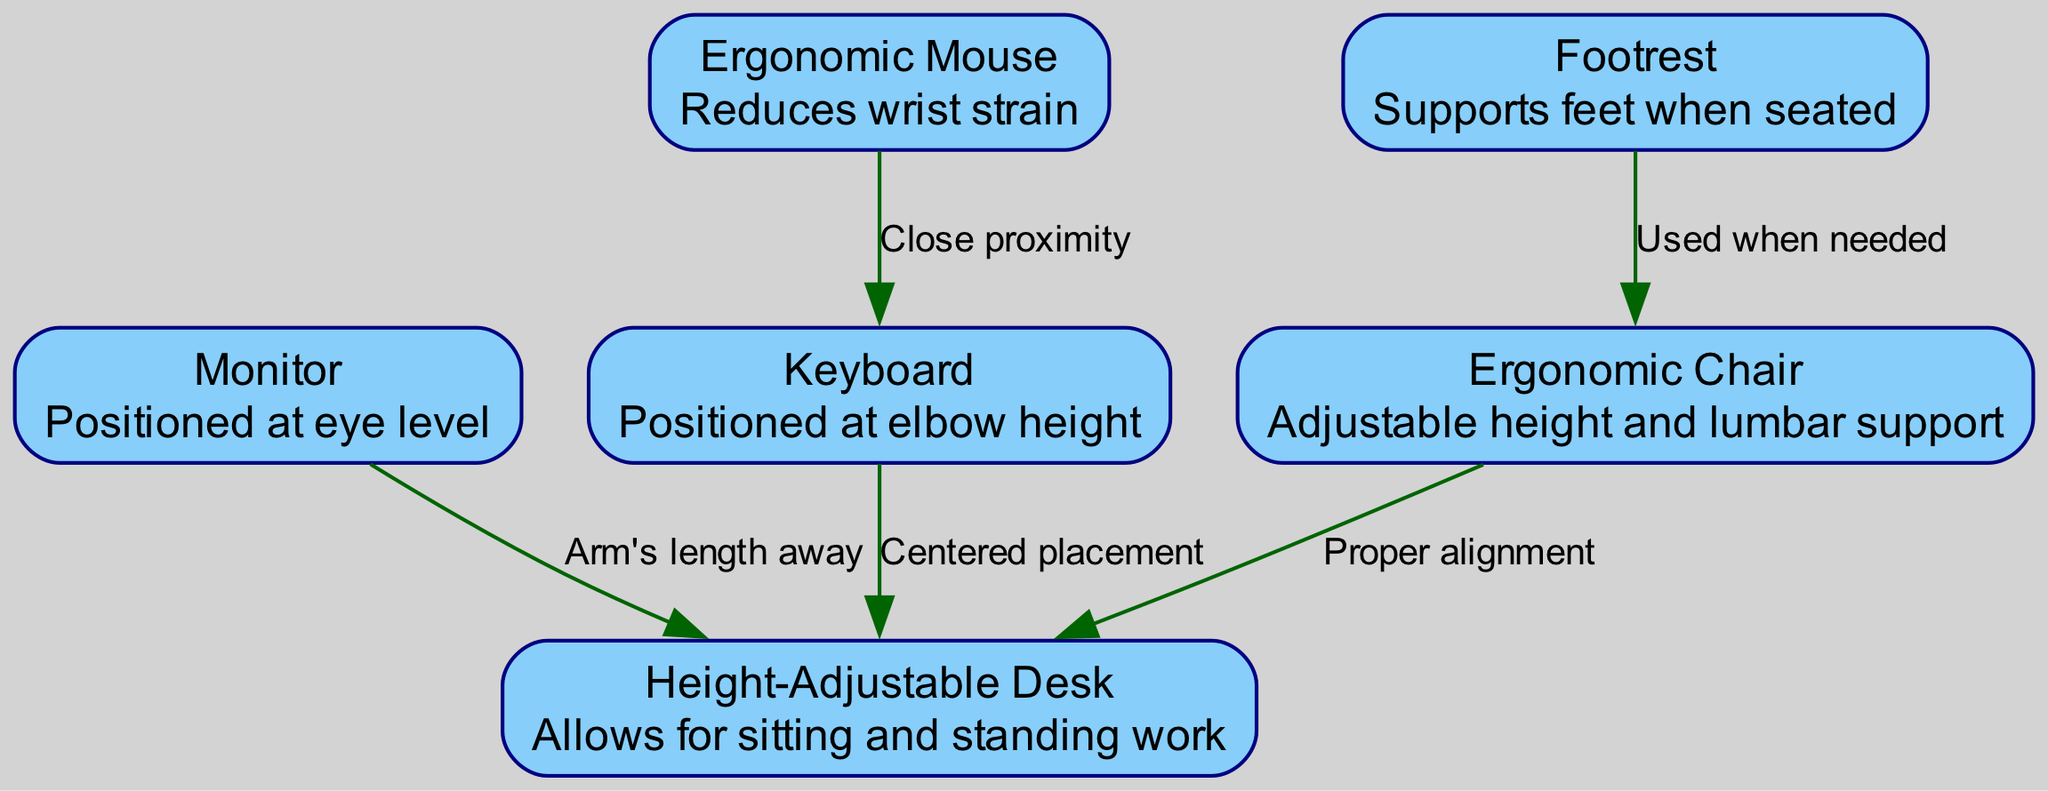What is the description of the Monitor node? The Monitor node is labeled "Monitor" and has a description stating that it is "Positioned at eye level." Therefore, the basic information about this node can be directly found in the diagram.
Answer: Positioned at eye level How many nodes are present in the diagram? The diagram contains a total of six nodes: Ergonomic Chair, Height-Adjustable Desk, Monitor, Keyboard, Ergonomic Mouse, and Footrest. By counting each node in the provided data, we can establish this number.
Answer: 6 What is the relationship between the Keyboard and the Desk? The edge connecting the Keyboard to the Desk is labeled "Centered placement." This indicates that the positioning of the keyboard should be centered with respect to the desk in the ergonomic setup.
Answer: Centered placement What support does the Footrest provide? The Footrest is described as providing "Supports feet when seated." This highlights its function in helping maintain a proper resting position for the feet during seated work.
Answer: Supports feet when seated What is the purpose of the Ergonomic Mouse? The Ergonomic Mouse is described as reducing "wrist strain." This indicates its design purpose is to prevent or mitigate strain on the wrist during use.
Answer: Reduces wrist strain Why should the Monitor be positioned at arm's length away? The Monitor is positioned at eye level, and the relationship states that it should be "Arm's length away." This is based on ergonomic principles to reduce eye strain and allow for a comfortable viewing distance, promoting healthy posture.
Answer: To reduce eye strain Which element is used when needed in relation to the Chair? The edge indicates that the Footrest is "Used when needed" in relation to the Chair. This means the footrest can be employed as necessary to enhance comfort while seated.
Answer: Used when needed What feature does the Height-Adjustable Desk offer? The Height-Adjustable Desk is described with the feature, "Allows for sitting and standing work." This characteristic uniquely identifies the function of the desk regarding posture flexibility.
Answer: Allows for sitting and standing work 